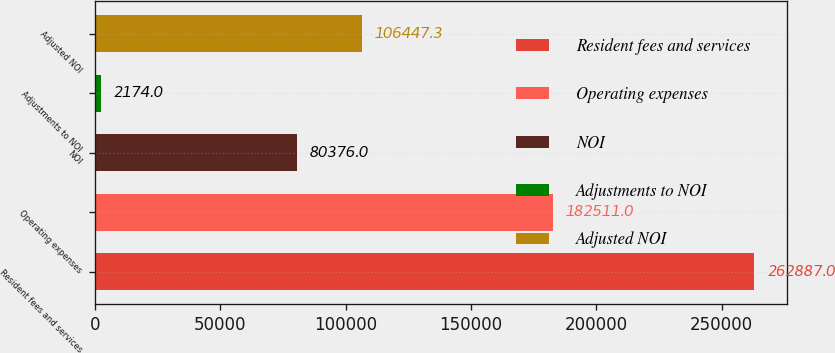Convert chart. <chart><loc_0><loc_0><loc_500><loc_500><bar_chart><fcel>Resident fees and services<fcel>Operating expenses<fcel>NOI<fcel>Adjustments to NOI<fcel>Adjusted NOI<nl><fcel>262887<fcel>182511<fcel>80376<fcel>2174<fcel>106447<nl></chart> 